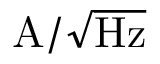Convert formula to latex. <formula><loc_0><loc_0><loc_500><loc_500>A / \sqrt { H z }</formula> 